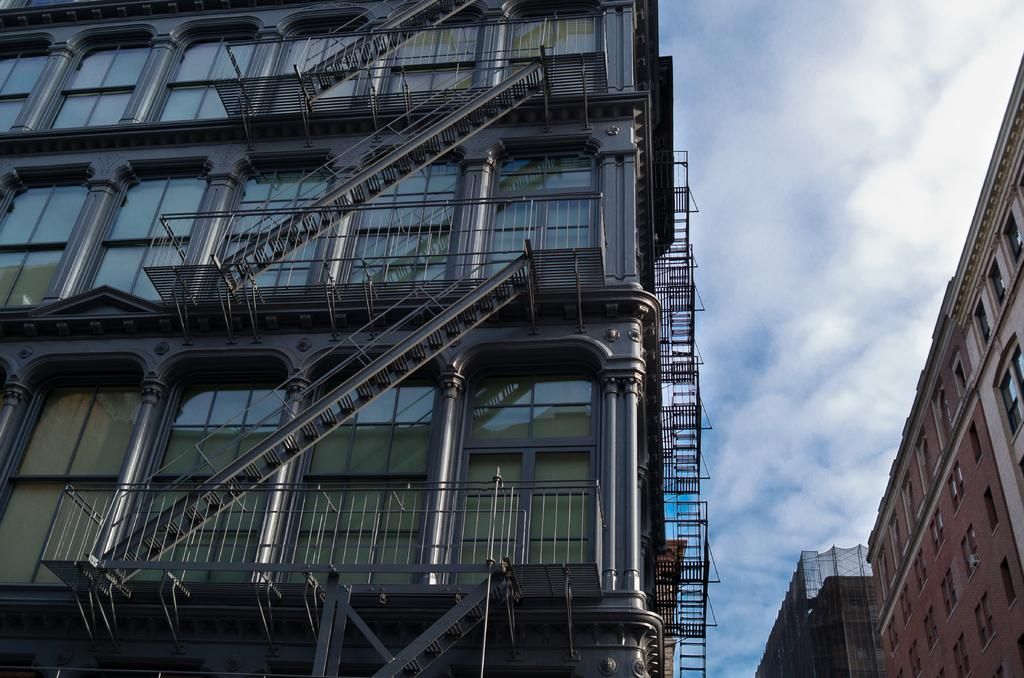What type of building is in the image? There is a glass building in the image. What features can be seen on the glass building? The glass building has pillars, railings, and stairs. What can be seen on the right side of the image? There are buildings, a wall, and glass windows visible on the right side of the image. What is visible in the sky in the image? The sky is visible in the image. What type of verse can be seen written on the glass building in the image? There is no verse visible on the glass building in the image. Is the bread in the image hot or cold? There is no bread present in the image. 